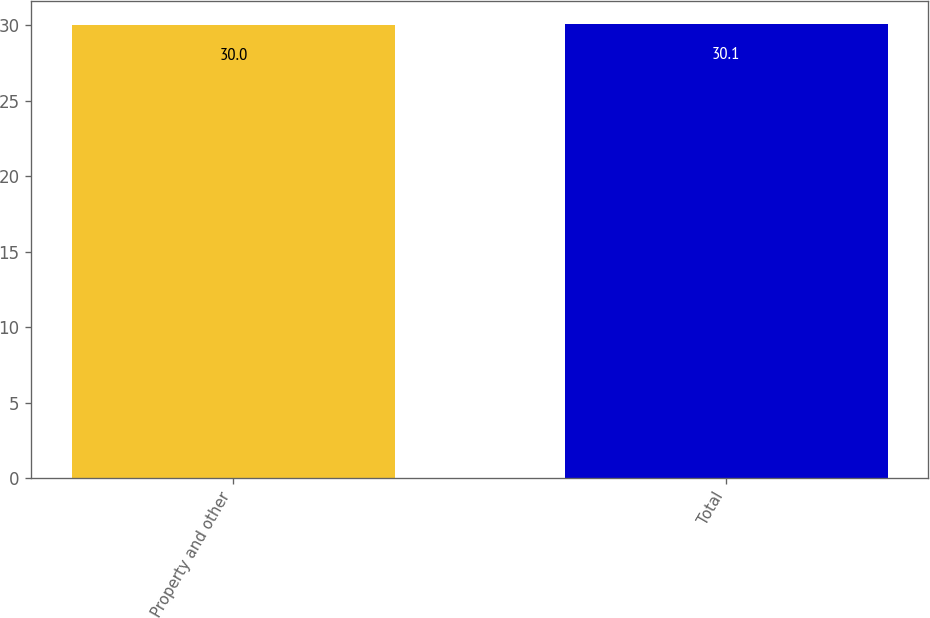Convert chart to OTSL. <chart><loc_0><loc_0><loc_500><loc_500><bar_chart><fcel>Property and other<fcel>Total<nl><fcel>30<fcel>30.1<nl></chart> 